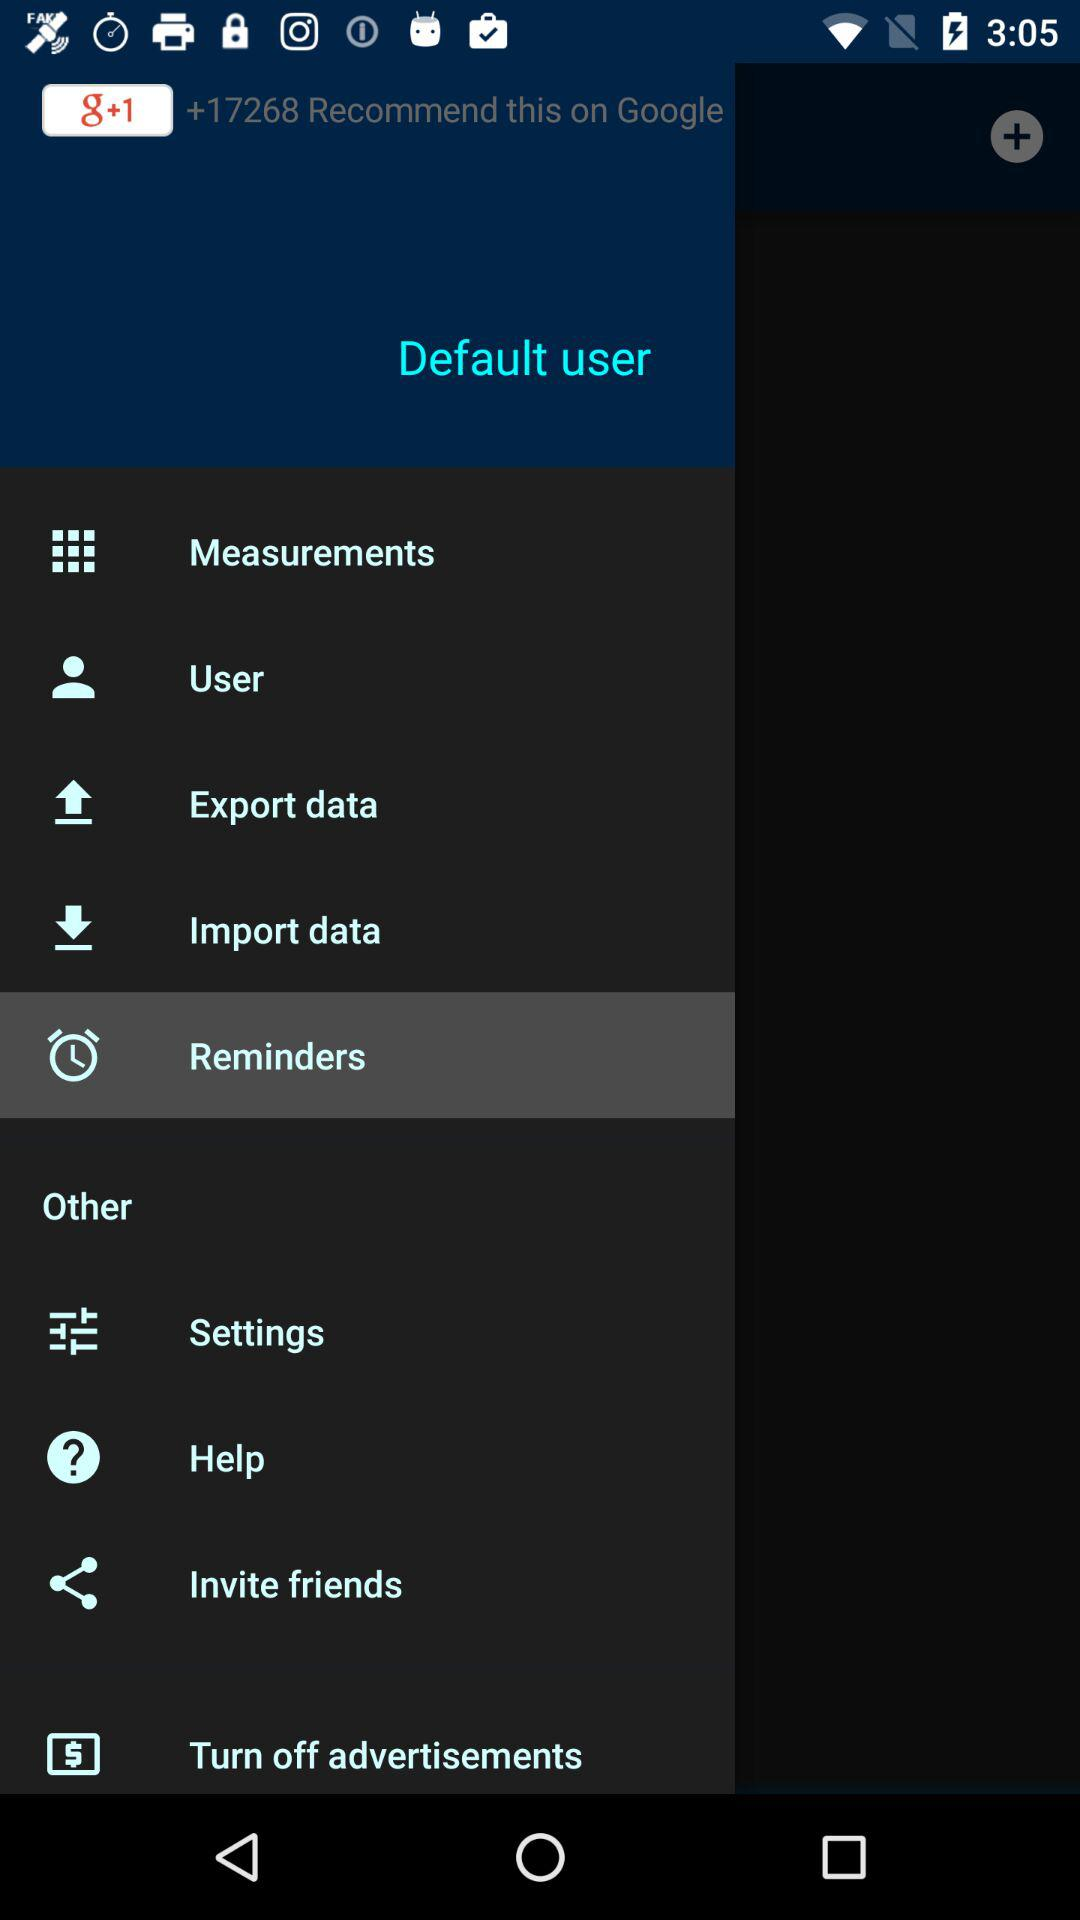How many recommendations are on "g+1"? There are more than +17268 recommendations on "g+1". 